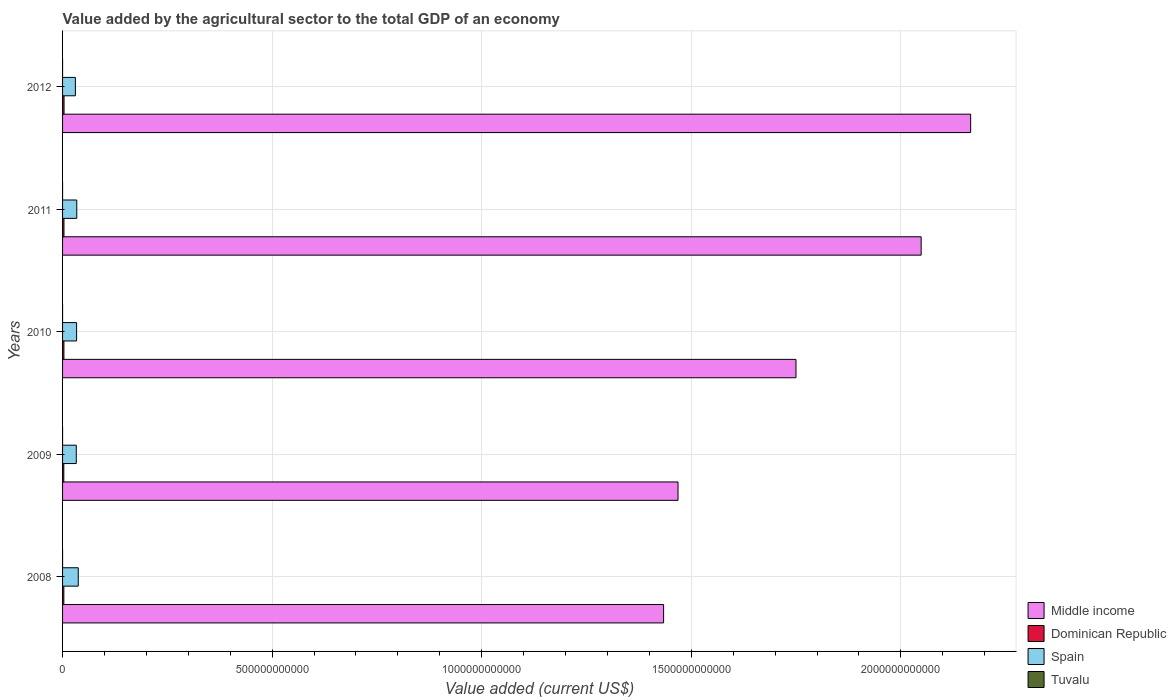How many different coloured bars are there?
Offer a very short reply. 4. How many groups of bars are there?
Your answer should be compact. 5. What is the label of the 1st group of bars from the top?
Keep it short and to the point. 2012. In how many cases, is the number of bars for a given year not equal to the number of legend labels?
Your answer should be compact. 0. What is the value added by the agricultural sector to the total GDP in Middle income in 2010?
Keep it short and to the point. 1.75e+12. Across all years, what is the maximum value added by the agricultural sector to the total GDP in Middle income?
Offer a very short reply. 2.17e+12. Across all years, what is the minimum value added by the agricultural sector to the total GDP in Dominican Republic?
Offer a very short reply. 2.97e+09. In which year was the value added by the agricultural sector to the total GDP in Tuvalu maximum?
Provide a succinct answer. 2011. What is the total value added by the agricultural sector to the total GDP in Dominican Republic in the graph?
Ensure brevity in your answer.  1.62e+1. What is the difference between the value added by the agricultural sector to the total GDP in Middle income in 2009 and that in 2010?
Your answer should be very brief. -2.81e+11. What is the difference between the value added by the agricultural sector to the total GDP in Spain in 2009 and the value added by the agricultural sector to the total GDP in Tuvalu in 2011?
Give a very brief answer. 3.27e+1. What is the average value added by the agricultural sector to the total GDP in Tuvalu per year?
Your answer should be very brief. 8.27e+06. In the year 2011, what is the difference between the value added by the agricultural sector to the total GDP in Middle income and value added by the agricultural sector to the total GDP in Dominican Republic?
Keep it short and to the point. 2.04e+12. What is the ratio of the value added by the agricultural sector to the total GDP in Dominican Republic in 2008 to that in 2009?
Ensure brevity in your answer.  1.03. Is the value added by the agricultural sector to the total GDP in Tuvalu in 2008 less than that in 2010?
Give a very brief answer. Yes. What is the difference between the highest and the second highest value added by the agricultural sector to the total GDP in Dominican Republic?
Offer a very short reply. 1.78e+08. What is the difference between the highest and the lowest value added by the agricultural sector to the total GDP in Tuvalu?
Give a very brief answer. 3.57e+06. In how many years, is the value added by the agricultural sector to the total GDP in Middle income greater than the average value added by the agricultural sector to the total GDP in Middle income taken over all years?
Provide a short and direct response. 2. What does the 1st bar from the top in 2012 represents?
Keep it short and to the point. Tuvalu. How many bars are there?
Your answer should be very brief. 20. Are all the bars in the graph horizontal?
Offer a very short reply. Yes. What is the difference between two consecutive major ticks on the X-axis?
Keep it short and to the point. 5.00e+11. Are the values on the major ticks of X-axis written in scientific E-notation?
Offer a very short reply. No. Where does the legend appear in the graph?
Offer a very short reply. Bottom right. How are the legend labels stacked?
Your response must be concise. Vertical. What is the title of the graph?
Offer a terse response. Value added by the agricultural sector to the total GDP of an economy. What is the label or title of the X-axis?
Provide a short and direct response. Value added (current US$). What is the Value added (current US$) in Middle income in 2008?
Provide a succinct answer. 1.43e+12. What is the Value added (current US$) in Dominican Republic in 2008?
Make the answer very short. 3.06e+09. What is the Value added (current US$) in Spain in 2008?
Provide a short and direct response. 3.74e+1. What is the Value added (current US$) of Tuvalu in 2008?
Your response must be concise. 6.70e+06. What is the Value added (current US$) in Middle income in 2009?
Your answer should be very brief. 1.47e+12. What is the Value added (current US$) of Dominican Republic in 2009?
Your response must be concise. 2.97e+09. What is the Value added (current US$) of Spain in 2009?
Provide a succinct answer. 3.27e+1. What is the Value added (current US$) of Tuvalu in 2009?
Your response must be concise. 6.55e+06. What is the Value added (current US$) in Middle income in 2010?
Provide a short and direct response. 1.75e+12. What is the Value added (current US$) of Dominican Republic in 2010?
Give a very brief answer. 3.25e+09. What is the Value added (current US$) in Spain in 2010?
Keep it short and to the point. 3.34e+1. What is the Value added (current US$) of Tuvalu in 2010?
Your answer should be compact. 8.51e+06. What is the Value added (current US$) of Middle income in 2011?
Provide a succinct answer. 2.05e+12. What is the Value added (current US$) of Dominican Republic in 2011?
Ensure brevity in your answer.  3.36e+09. What is the Value added (current US$) of Spain in 2011?
Your answer should be compact. 3.39e+1. What is the Value added (current US$) in Tuvalu in 2011?
Your answer should be very brief. 1.01e+07. What is the Value added (current US$) in Middle income in 2012?
Provide a succinct answer. 2.17e+12. What is the Value added (current US$) of Dominican Republic in 2012?
Offer a very short reply. 3.54e+09. What is the Value added (current US$) in Spain in 2012?
Provide a succinct answer. 3.06e+1. What is the Value added (current US$) in Tuvalu in 2012?
Ensure brevity in your answer.  9.49e+06. Across all years, what is the maximum Value added (current US$) in Middle income?
Your response must be concise. 2.17e+12. Across all years, what is the maximum Value added (current US$) in Dominican Republic?
Keep it short and to the point. 3.54e+09. Across all years, what is the maximum Value added (current US$) in Spain?
Keep it short and to the point. 3.74e+1. Across all years, what is the maximum Value added (current US$) of Tuvalu?
Provide a succinct answer. 1.01e+07. Across all years, what is the minimum Value added (current US$) of Middle income?
Your answer should be very brief. 1.43e+12. Across all years, what is the minimum Value added (current US$) in Dominican Republic?
Keep it short and to the point. 2.97e+09. Across all years, what is the minimum Value added (current US$) in Spain?
Offer a terse response. 3.06e+1. Across all years, what is the minimum Value added (current US$) in Tuvalu?
Keep it short and to the point. 6.55e+06. What is the total Value added (current US$) of Middle income in the graph?
Ensure brevity in your answer.  8.87e+12. What is the total Value added (current US$) of Dominican Republic in the graph?
Give a very brief answer. 1.62e+1. What is the total Value added (current US$) of Spain in the graph?
Provide a short and direct response. 1.68e+11. What is the total Value added (current US$) in Tuvalu in the graph?
Offer a very short reply. 4.14e+07. What is the difference between the Value added (current US$) in Middle income in 2008 and that in 2009?
Your answer should be compact. -3.44e+1. What is the difference between the Value added (current US$) of Dominican Republic in 2008 and that in 2009?
Make the answer very short. 9.07e+07. What is the difference between the Value added (current US$) in Spain in 2008 and that in 2009?
Give a very brief answer. 4.73e+09. What is the difference between the Value added (current US$) of Tuvalu in 2008 and that in 2009?
Your answer should be very brief. 1.44e+05. What is the difference between the Value added (current US$) of Middle income in 2008 and that in 2010?
Keep it short and to the point. -3.16e+11. What is the difference between the Value added (current US$) of Dominican Republic in 2008 and that in 2010?
Give a very brief answer. -1.86e+08. What is the difference between the Value added (current US$) in Spain in 2008 and that in 2010?
Your response must be concise. 3.99e+09. What is the difference between the Value added (current US$) in Tuvalu in 2008 and that in 2010?
Your answer should be compact. -1.82e+06. What is the difference between the Value added (current US$) in Middle income in 2008 and that in 2011?
Give a very brief answer. -6.14e+11. What is the difference between the Value added (current US$) of Dominican Republic in 2008 and that in 2011?
Your answer should be very brief. -3.04e+08. What is the difference between the Value added (current US$) of Spain in 2008 and that in 2011?
Offer a very short reply. 3.54e+09. What is the difference between the Value added (current US$) in Tuvalu in 2008 and that in 2011?
Ensure brevity in your answer.  -3.43e+06. What is the difference between the Value added (current US$) of Middle income in 2008 and that in 2012?
Your answer should be very brief. -7.32e+11. What is the difference between the Value added (current US$) in Dominican Republic in 2008 and that in 2012?
Ensure brevity in your answer.  -4.82e+08. What is the difference between the Value added (current US$) in Spain in 2008 and that in 2012?
Keep it short and to the point. 6.84e+09. What is the difference between the Value added (current US$) in Tuvalu in 2008 and that in 2012?
Provide a short and direct response. -2.79e+06. What is the difference between the Value added (current US$) of Middle income in 2009 and that in 2010?
Offer a very short reply. -2.81e+11. What is the difference between the Value added (current US$) in Dominican Republic in 2009 and that in 2010?
Make the answer very short. -2.76e+08. What is the difference between the Value added (current US$) of Spain in 2009 and that in 2010?
Your answer should be compact. -7.32e+08. What is the difference between the Value added (current US$) of Tuvalu in 2009 and that in 2010?
Offer a very short reply. -1.96e+06. What is the difference between the Value added (current US$) in Middle income in 2009 and that in 2011?
Make the answer very short. -5.80e+11. What is the difference between the Value added (current US$) in Dominican Republic in 2009 and that in 2011?
Make the answer very short. -3.95e+08. What is the difference between the Value added (current US$) in Spain in 2009 and that in 2011?
Make the answer very short. -1.19e+09. What is the difference between the Value added (current US$) of Tuvalu in 2009 and that in 2011?
Ensure brevity in your answer.  -3.57e+06. What is the difference between the Value added (current US$) in Middle income in 2009 and that in 2012?
Keep it short and to the point. -6.98e+11. What is the difference between the Value added (current US$) in Dominican Republic in 2009 and that in 2012?
Make the answer very short. -5.73e+08. What is the difference between the Value added (current US$) in Spain in 2009 and that in 2012?
Provide a succinct answer. 2.11e+09. What is the difference between the Value added (current US$) of Tuvalu in 2009 and that in 2012?
Keep it short and to the point. -2.93e+06. What is the difference between the Value added (current US$) of Middle income in 2010 and that in 2011?
Provide a succinct answer. -2.99e+11. What is the difference between the Value added (current US$) of Dominican Republic in 2010 and that in 2011?
Provide a short and direct response. -1.19e+08. What is the difference between the Value added (current US$) of Spain in 2010 and that in 2011?
Offer a terse response. -4.57e+08. What is the difference between the Value added (current US$) of Tuvalu in 2010 and that in 2011?
Ensure brevity in your answer.  -1.61e+06. What is the difference between the Value added (current US$) in Middle income in 2010 and that in 2012?
Ensure brevity in your answer.  -4.17e+11. What is the difference between the Value added (current US$) of Dominican Republic in 2010 and that in 2012?
Make the answer very short. -2.97e+08. What is the difference between the Value added (current US$) of Spain in 2010 and that in 2012?
Keep it short and to the point. 2.85e+09. What is the difference between the Value added (current US$) in Tuvalu in 2010 and that in 2012?
Give a very brief answer. -9.75e+05. What is the difference between the Value added (current US$) of Middle income in 2011 and that in 2012?
Your answer should be very brief. -1.18e+11. What is the difference between the Value added (current US$) in Dominican Republic in 2011 and that in 2012?
Provide a succinct answer. -1.78e+08. What is the difference between the Value added (current US$) of Spain in 2011 and that in 2012?
Keep it short and to the point. 3.30e+09. What is the difference between the Value added (current US$) of Tuvalu in 2011 and that in 2012?
Your answer should be compact. 6.35e+05. What is the difference between the Value added (current US$) in Middle income in 2008 and the Value added (current US$) in Dominican Republic in 2009?
Give a very brief answer. 1.43e+12. What is the difference between the Value added (current US$) of Middle income in 2008 and the Value added (current US$) of Spain in 2009?
Offer a very short reply. 1.40e+12. What is the difference between the Value added (current US$) in Middle income in 2008 and the Value added (current US$) in Tuvalu in 2009?
Give a very brief answer. 1.43e+12. What is the difference between the Value added (current US$) of Dominican Republic in 2008 and the Value added (current US$) of Spain in 2009?
Keep it short and to the point. -2.97e+1. What is the difference between the Value added (current US$) of Dominican Republic in 2008 and the Value added (current US$) of Tuvalu in 2009?
Your response must be concise. 3.05e+09. What is the difference between the Value added (current US$) in Spain in 2008 and the Value added (current US$) in Tuvalu in 2009?
Make the answer very short. 3.74e+1. What is the difference between the Value added (current US$) in Middle income in 2008 and the Value added (current US$) in Dominican Republic in 2010?
Make the answer very short. 1.43e+12. What is the difference between the Value added (current US$) of Middle income in 2008 and the Value added (current US$) of Spain in 2010?
Offer a terse response. 1.40e+12. What is the difference between the Value added (current US$) of Middle income in 2008 and the Value added (current US$) of Tuvalu in 2010?
Keep it short and to the point. 1.43e+12. What is the difference between the Value added (current US$) of Dominican Republic in 2008 and the Value added (current US$) of Spain in 2010?
Your response must be concise. -3.04e+1. What is the difference between the Value added (current US$) in Dominican Republic in 2008 and the Value added (current US$) in Tuvalu in 2010?
Keep it short and to the point. 3.05e+09. What is the difference between the Value added (current US$) of Spain in 2008 and the Value added (current US$) of Tuvalu in 2010?
Keep it short and to the point. 3.74e+1. What is the difference between the Value added (current US$) in Middle income in 2008 and the Value added (current US$) in Dominican Republic in 2011?
Your answer should be compact. 1.43e+12. What is the difference between the Value added (current US$) in Middle income in 2008 and the Value added (current US$) in Spain in 2011?
Ensure brevity in your answer.  1.40e+12. What is the difference between the Value added (current US$) in Middle income in 2008 and the Value added (current US$) in Tuvalu in 2011?
Keep it short and to the point. 1.43e+12. What is the difference between the Value added (current US$) of Dominican Republic in 2008 and the Value added (current US$) of Spain in 2011?
Offer a very short reply. -3.08e+1. What is the difference between the Value added (current US$) of Dominican Republic in 2008 and the Value added (current US$) of Tuvalu in 2011?
Your answer should be compact. 3.05e+09. What is the difference between the Value added (current US$) in Spain in 2008 and the Value added (current US$) in Tuvalu in 2011?
Your answer should be compact. 3.74e+1. What is the difference between the Value added (current US$) of Middle income in 2008 and the Value added (current US$) of Dominican Republic in 2012?
Give a very brief answer. 1.43e+12. What is the difference between the Value added (current US$) in Middle income in 2008 and the Value added (current US$) in Spain in 2012?
Keep it short and to the point. 1.40e+12. What is the difference between the Value added (current US$) of Middle income in 2008 and the Value added (current US$) of Tuvalu in 2012?
Offer a terse response. 1.43e+12. What is the difference between the Value added (current US$) of Dominican Republic in 2008 and the Value added (current US$) of Spain in 2012?
Ensure brevity in your answer.  -2.75e+1. What is the difference between the Value added (current US$) of Dominican Republic in 2008 and the Value added (current US$) of Tuvalu in 2012?
Give a very brief answer. 3.05e+09. What is the difference between the Value added (current US$) of Spain in 2008 and the Value added (current US$) of Tuvalu in 2012?
Ensure brevity in your answer.  3.74e+1. What is the difference between the Value added (current US$) in Middle income in 2009 and the Value added (current US$) in Dominican Republic in 2010?
Make the answer very short. 1.47e+12. What is the difference between the Value added (current US$) in Middle income in 2009 and the Value added (current US$) in Spain in 2010?
Your answer should be compact. 1.43e+12. What is the difference between the Value added (current US$) in Middle income in 2009 and the Value added (current US$) in Tuvalu in 2010?
Provide a succinct answer. 1.47e+12. What is the difference between the Value added (current US$) of Dominican Republic in 2009 and the Value added (current US$) of Spain in 2010?
Offer a terse response. -3.05e+1. What is the difference between the Value added (current US$) in Dominican Republic in 2009 and the Value added (current US$) in Tuvalu in 2010?
Give a very brief answer. 2.96e+09. What is the difference between the Value added (current US$) in Spain in 2009 and the Value added (current US$) in Tuvalu in 2010?
Offer a terse response. 3.27e+1. What is the difference between the Value added (current US$) of Middle income in 2009 and the Value added (current US$) of Dominican Republic in 2011?
Keep it short and to the point. 1.46e+12. What is the difference between the Value added (current US$) of Middle income in 2009 and the Value added (current US$) of Spain in 2011?
Keep it short and to the point. 1.43e+12. What is the difference between the Value added (current US$) of Middle income in 2009 and the Value added (current US$) of Tuvalu in 2011?
Provide a succinct answer. 1.47e+12. What is the difference between the Value added (current US$) of Dominican Republic in 2009 and the Value added (current US$) of Spain in 2011?
Give a very brief answer. -3.09e+1. What is the difference between the Value added (current US$) of Dominican Republic in 2009 and the Value added (current US$) of Tuvalu in 2011?
Provide a short and direct response. 2.96e+09. What is the difference between the Value added (current US$) of Spain in 2009 and the Value added (current US$) of Tuvalu in 2011?
Give a very brief answer. 3.27e+1. What is the difference between the Value added (current US$) of Middle income in 2009 and the Value added (current US$) of Dominican Republic in 2012?
Your response must be concise. 1.46e+12. What is the difference between the Value added (current US$) in Middle income in 2009 and the Value added (current US$) in Spain in 2012?
Provide a succinct answer. 1.44e+12. What is the difference between the Value added (current US$) of Middle income in 2009 and the Value added (current US$) of Tuvalu in 2012?
Give a very brief answer. 1.47e+12. What is the difference between the Value added (current US$) of Dominican Republic in 2009 and the Value added (current US$) of Spain in 2012?
Offer a very short reply. -2.76e+1. What is the difference between the Value added (current US$) in Dominican Republic in 2009 and the Value added (current US$) in Tuvalu in 2012?
Keep it short and to the point. 2.96e+09. What is the difference between the Value added (current US$) of Spain in 2009 and the Value added (current US$) of Tuvalu in 2012?
Offer a very short reply. 3.27e+1. What is the difference between the Value added (current US$) in Middle income in 2010 and the Value added (current US$) in Dominican Republic in 2011?
Provide a succinct answer. 1.75e+12. What is the difference between the Value added (current US$) in Middle income in 2010 and the Value added (current US$) in Spain in 2011?
Provide a succinct answer. 1.72e+12. What is the difference between the Value added (current US$) in Middle income in 2010 and the Value added (current US$) in Tuvalu in 2011?
Keep it short and to the point. 1.75e+12. What is the difference between the Value added (current US$) in Dominican Republic in 2010 and the Value added (current US$) in Spain in 2011?
Give a very brief answer. -3.07e+1. What is the difference between the Value added (current US$) of Dominican Republic in 2010 and the Value added (current US$) of Tuvalu in 2011?
Offer a terse response. 3.23e+09. What is the difference between the Value added (current US$) in Spain in 2010 and the Value added (current US$) in Tuvalu in 2011?
Offer a very short reply. 3.34e+1. What is the difference between the Value added (current US$) in Middle income in 2010 and the Value added (current US$) in Dominican Republic in 2012?
Provide a succinct answer. 1.75e+12. What is the difference between the Value added (current US$) of Middle income in 2010 and the Value added (current US$) of Spain in 2012?
Offer a terse response. 1.72e+12. What is the difference between the Value added (current US$) of Middle income in 2010 and the Value added (current US$) of Tuvalu in 2012?
Keep it short and to the point. 1.75e+12. What is the difference between the Value added (current US$) in Dominican Republic in 2010 and the Value added (current US$) in Spain in 2012?
Keep it short and to the point. -2.74e+1. What is the difference between the Value added (current US$) of Dominican Republic in 2010 and the Value added (current US$) of Tuvalu in 2012?
Provide a short and direct response. 3.24e+09. What is the difference between the Value added (current US$) of Spain in 2010 and the Value added (current US$) of Tuvalu in 2012?
Provide a succinct answer. 3.34e+1. What is the difference between the Value added (current US$) in Middle income in 2011 and the Value added (current US$) in Dominican Republic in 2012?
Provide a short and direct response. 2.04e+12. What is the difference between the Value added (current US$) in Middle income in 2011 and the Value added (current US$) in Spain in 2012?
Offer a terse response. 2.02e+12. What is the difference between the Value added (current US$) of Middle income in 2011 and the Value added (current US$) of Tuvalu in 2012?
Your answer should be very brief. 2.05e+12. What is the difference between the Value added (current US$) in Dominican Republic in 2011 and the Value added (current US$) in Spain in 2012?
Keep it short and to the point. -2.72e+1. What is the difference between the Value added (current US$) of Dominican Republic in 2011 and the Value added (current US$) of Tuvalu in 2012?
Make the answer very short. 3.35e+09. What is the difference between the Value added (current US$) in Spain in 2011 and the Value added (current US$) in Tuvalu in 2012?
Your answer should be very brief. 3.39e+1. What is the average Value added (current US$) of Middle income per year?
Make the answer very short. 1.77e+12. What is the average Value added (current US$) in Dominican Republic per year?
Give a very brief answer. 3.24e+09. What is the average Value added (current US$) in Spain per year?
Ensure brevity in your answer.  3.36e+1. What is the average Value added (current US$) of Tuvalu per year?
Offer a terse response. 8.27e+06. In the year 2008, what is the difference between the Value added (current US$) of Middle income and Value added (current US$) of Dominican Republic?
Provide a succinct answer. 1.43e+12. In the year 2008, what is the difference between the Value added (current US$) in Middle income and Value added (current US$) in Spain?
Offer a very short reply. 1.40e+12. In the year 2008, what is the difference between the Value added (current US$) in Middle income and Value added (current US$) in Tuvalu?
Give a very brief answer. 1.43e+12. In the year 2008, what is the difference between the Value added (current US$) in Dominican Republic and Value added (current US$) in Spain?
Your answer should be compact. -3.44e+1. In the year 2008, what is the difference between the Value added (current US$) in Dominican Republic and Value added (current US$) in Tuvalu?
Provide a short and direct response. 3.05e+09. In the year 2008, what is the difference between the Value added (current US$) of Spain and Value added (current US$) of Tuvalu?
Ensure brevity in your answer.  3.74e+1. In the year 2009, what is the difference between the Value added (current US$) of Middle income and Value added (current US$) of Dominican Republic?
Your answer should be compact. 1.47e+12. In the year 2009, what is the difference between the Value added (current US$) of Middle income and Value added (current US$) of Spain?
Give a very brief answer. 1.44e+12. In the year 2009, what is the difference between the Value added (current US$) in Middle income and Value added (current US$) in Tuvalu?
Offer a terse response. 1.47e+12. In the year 2009, what is the difference between the Value added (current US$) of Dominican Republic and Value added (current US$) of Spain?
Ensure brevity in your answer.  -2.97e+1. In the year 2009, what is the difference between the Value added (current US$) in Dominican Republic and Value added (current US$) in Tuvalu?
Your response must be concise. 2.96e+09. In the year 2009, what is the difference between the Value added (current US$) in Spain and Value added (current US$) in Tuvalu?
Offer a very short reply. 3.27e+1. In the year 2010, what is the difference between the Value added (current US$) in Middle income and Value added (current US$) in Dominican Republic?
Your answer should be compact. 1.75e+12. In the year 2010, what is the difference between the Value added (current US$) in Middle income and Value added (current US$) in Spain?
Ensure brevity in your answer.  1.72e+12. In the year 2010, what is the difference between the Value added (current US$) in Middle income and Value added (current US$) in Tuvalu?
Your answer should be compact. 1.75e+12. In the year 2010, what is the difference between the Value added (current US$) of Dominican Republic and Value added (current US$) of Spain?
Make the answer very short. -3.02e+1. In the year 2010, what is the difference between the Value added (current US$) in Dominican Republic and Value added (current US$) in Tuvalu?
Offer a very short reply. 3.24e+09. In the year 2010, what is the difference between the Value added (current US$) of Spain and Value added (current US$) of Tuvalu?
Offer a very short reply. 3.34e+1. In the year 2011, what is the difference between the Value added (current US$) in Middle income and Value added (current US$) in Dominican Republic?
Your response must be concise. 2.04e+12. In the year 2011, what is the difference between the Value added (current US$) of Middle income and Value added (current US$) of Spain?
Keep it short and to the point. 2.01e+12. In the year 2011, what is the difference between the Value added (current US$) of Middle income and Value added (current US$) of Tuvalu?
Ensure brevity in your answer.  2.05e+12. In the year 2011, what is the difference between the Value added (current US$) in Dominican Republic and Value added (current US$) in Spain?
Provide a short and direct response. -3.05e+1. In the year 2011, what is the difference between the Value added (current US$) in Dominican Republic and Value added (current US$) in Tuvalu?
Offer a very short reply. 3.35e+09. In the year 2011, what is the difference between the Value added (current US$) of Spain and Value added (current US$) of Tuvalu?
Offer a terse response. 3.39e+1. In the year 2012, what is the difference between the Value added (current US$) in Middle income and Value added (current US$) in Dominican Republic?
Your answer should be compact. 2.16e+12. In the year 2012, what is the difference between the Value added (current US$) of Middle income and Value added (current US$) of Spain?
Your answer should be very brief. 2.14e+12. In the year 2012, what is the difference between the Value added (current US$) in Middle income and Value added (current US$) in Tuvalu?
Ensure brevity in your answer.  2.17e+12. In the year 2012, what is the difference between the Value added (current US$) in Dominican Republic and Value added (current US$) in Spain?
Give a very brief answer. -2.71e+1. In the year 2012, what is the difference between the Value added (current US$) of Dominican Republic and Value added (current US$) of Tuvalu?
Ensure brevity in your answer.  3.53e+09. In the year 2012, what is the difference between the Value added (current US$) in Spain and Value added (current US$) in Tuvalu?
Provide a succinct answer. 3.06e+1. What is the ratio of the Value added (current US$) in Middle income in 2008 to that in 2009?
Your answer should be compact. 0.98. What is the ratio of the Value added (current US$) of Dominican Republic in 2008 to that in 2009?
Provide a short and direct response. 1.03. What is the ratio of the Value added (current US$) in Spain in 2008 to that in 2009?
Offer a very short reply. 1.14. What is the ratio of the Value added (current US$) in Middle income in 2008 to that in 2010?
Provide a succinct answer. 0.82. What is the ratio of the Value added (current US$) in Dominican Republic in 2008 to that in 2010?
Offer a very short reply. 0.94. What is the ratio of the Value added (current US$) of Spain in 2008 to that in 2010?
Keep it short and to the point. 1.12. What is the ratio of the Value added (current US$) in Tuvalu in 2008 to that in 2010?
Offer a terse response. 0.79. What is the ratio of the Value added (current US$) of Middle income in 2008 to that in 2011?
Provide a short and direct response. 0.7. What is the ratio of the Value added (current US$) of Dominican Republic in 2008 to that in 2011?
Make the answer very short. 0.91. What is the ratio of the Value added (current US$) in Spain in 2008 to that in 2011?
Keep it short and to the point. 1.1. What is the ratio of the Value added (current US$) in Tuvalu in 2008 to that in 2011?
Ensure brevity in your answer.  0.66. What is the ratio of the Value added (current US$) of Middle income in 2008 to that in 2012?
Your answer should be very brief. 0.66. What is the ratio of the Value added (current US$) of Dominican Republic in 2008 to that in 2012?
Offer a terse response. 0.86. What is the ratio of the Value added (current US$) in Spain in 2008 to that in 2012?
Offer a very short reply. 1.22. What is the ratio of the Value added (current US$) in Tuvalu in 2008 to that in 2012?
Your answer should be very brief. 0.71. What is the ratio of the Value added (current US$) in Middle income in 2009 to that in 2010?
Make the answer very short. 0.84. What is the ratio of the Value added (current US$) of Dominican Republic in 2009 to that in 2010?
Make the answer very short. 0.91. What is the ratio of the Value added (current US$) of Spain in 2009 to that in 2010?
Give a very brief answer. 0.98. What is the ratio of the Value added (current US$) in Tuvalu in 2009 to that in 2010?
Keep it short and to the point. 0.77. What is the ratio of the Value added (current US$) in Middle income in 2009 to that in 2011?
Give a very brief answer. 0.72. What is the ratio of the Value added (current US$) of Dominican Republic in 2009 to that in 2011?
Keep it short and to the point. 0.88. What is the ratio of the Value added (current US$) of Spain in 2009 to that in 2011?
Your response must be concise. 0.96. What is the ratio of the Value added (current US$) in Tuvalu in 2009 to that in 2011?
Provide a short and direct response. 0.65. What is the ratio of the Value added (current US$) in Middle income in 2009 to that in 2012?
Keep it short and to the point. 0.68. What is the ratio of the Value added (current US$) in Dominican Republic in 2009 to that in 2012?
Keep it short and to the point. 0.84. What is the ratio of the Value added (current US$) of Spain in 2009 to that in 2012?
Your response must be concise. 1.07. What is the ratio of the Value added (current US$) of Tuvalu in 2009 to that in 2012?
Your answer should be compact. 0.69. What is the ratio of the Value added (current US$) of Middle income in 2010 to that in 2011?
Offer a terse response. 0.85. What is the ratio of the Value added (current US$) of Dominican Republic in 2010 to that in 2011?
Your response must be concise. 0.96. What is the ratio of the Value added (current US$) in Spain in 2010 to that in 2011?
Make the answer very short. 0.99. What is the ratio of the Value added (current US$) in Tuvalu in 2010 to that in 2011?
Offer a terse response. 0.84. What is the ratio of the Value added (current US$) of Middle income in 2010 to that in 2012?
Provide a succinct answer. 0.81. What is the ratio of the Value added (current US$) in Dominican Republic in 2010 to that in 2012?
Your answer should be very brief. 0.92. What is the ratio of the Value added (current US$) of Spain in 2010 to that in 2012?
Offer a very short reply. 1.09. What is the ratio of the Value added (current US$) of Tuvalu in 2010 to that in 2012?
Provide a short and direct response. 0.9. What is the ratio of the Value added (current US$) of Middle income in 2011 to that in 2012?
Your response must be concise. 0.95. What is the ratio of the Value added (current US$) of Dominican Republic in 2011 to that in 2012?
Provide a succinct answer. 0.95. What is the ratio of the Value added (current US$) in Spain in 2011 to that in 2012?
Your response must be concise. 1.11. What is the ratio of the Value added (current US$) in Tuvalu in 2011 to that in 2012?
Your answer should be very brief. 1.07. What is the difference between the highest and the second highest Value added (current US$) in Middle income?
Your answer should be compact. 1.18e+11. What is the difference between the highest and the second highest Value added (current US$) of Dominican Republic?
Provide a short and direct response. 1.78e+08. What is the difference between the highest and the second highest Value added (current US$) in Spain?
Provide a short and direct response. 3.54e+09. What is the difference between the highest and the second highest Value added (current US$) in Tuvalu?
Your answer should be very brief. 6.35e+05. What is the difference between the highest and the lowest Value added (current US$) of Middle income?
Your answer should be compact. 7.32e+11. What is the difference between the highest and the lowest Value added (current US$) of Dominican Republic?
Ensure brevity in your answer.  5.73e+08. What is the difference between the highest and the lowest Value added (current US$) in Spain?
Your response must be concise. 6.84e+09. What is the difference between the highest and the lowest Value added (current US$) of Tuvalu?
Ensure brevity in your answer.  3.57e+06. 